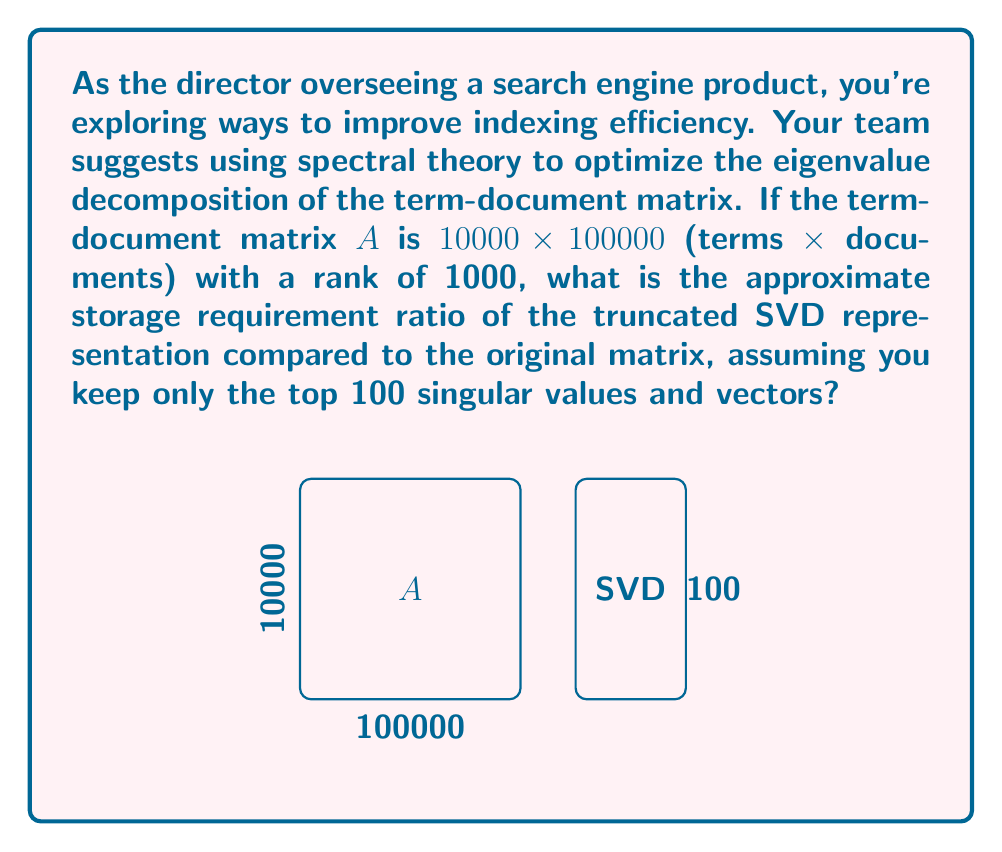Give your solution to this math problem. Let's approach this step-by-step:

1) The original term-document matrix $A$ has dimensions $10000 \times 100000$. Its storage requirement is:
   $$10000 \times 100000 = 10^9$$ elements

2) In the truncated SVD representation, we keep only the top 100 singular values and vectors. This gives us:
   - A left singular vector matrix $U$ of size $10000 \times 100$
   - A diagonal matrix $\Sigma$ of size $100 \times 100$ (only diagonal elements are stored)
   - A right singular vector matrix $V^T$ of size $100 \times 100000$

3) The storage requirement for the truncated SVD is:
   $$10000 \times 100 + 100 + 100 \times 100000 = 1,000,000 + 100 + 10,000,000 = 11,000,100$$ elements

4) The ratio of storage requirements is:
   $$\frac{\text{SVD storage}}{\text{Original storage}} = \frac{11,000,100}{10^9} \approx 0.011$$

5) To express this as a percentage, we multiply by 100:
   $$0.011 \times 100 \approx 1.1\%$$

Therefore, the truncated SVD representation requires approximately 1.1% of the storage space of the original matrix.
Answer: 1.1% 